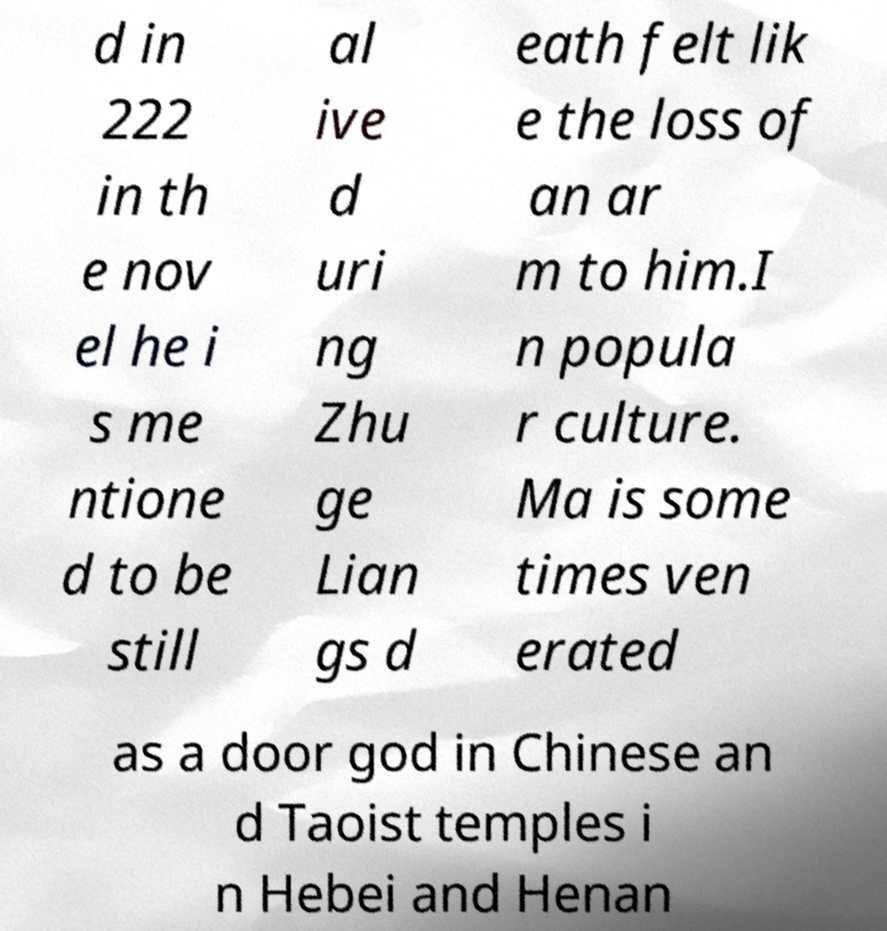Please identify and transcribe the text found in this image. d in 222 in th e nov el he i s me ntione d to be still al ive d uri ng Zhu ge Lian gs d eath felt lik e the loss of an ar m to him.I n popula r culture. Ma is some times ven erated as a door god in Chinese an d Taoist temples i n Hebei and Henan 